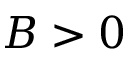<formula> <loc_0><loc_0><loc_500><loc_500>B > 0</formula> 